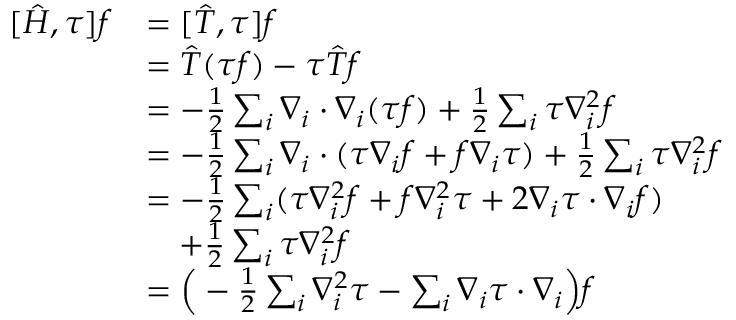Convert formula to latex. <formula><loc_0><loc_0><loc_500><loc_500>\begin{array} { r l } { [ \hat { H } , \tau ] f } & { = [ \hat { T } , \tau ] f } \\ & { = \hat { T } ( \tau f ) - \tau \hat { T } f } \\ & { = - \frac { 1 } { 2 } \sum _ { i } \nabla _ { i } \cdot \nabla _ { i } ( \tau f ) + \frac { 1 } { 2 } \sum _ { i } \tau \nabla _ { i } ^ { 2 } f } \\ & { = - \frac { 1 } { 2 } \sum _ { i } \nabla _ { i } \cdot ( \tau \nabla _ { i } f + f \nabla _ { i } \tau ) + \frac { 1 } { 2 } \sum _ { i } \tau \nabla _ { i } ^ { 2 } f } \\ & { = - \frac { 1 } { 2 } \sum _ { i } ( \tau \nabla _ { i } ^ { 2 } f + f \nabla _ { i } ^ { 2 } \tau + 2 \nabla _ { i } \tau \cdot \nabla _ { i } f ) } \\ & { \quad + \frac { 1 } { 2 } \sum _ { i } \tau \nabla _ { i } ^ { 2 } f } \\ & { = \left ( - \frac { 1 } { 2 } \sum _ { i } \nabla _ { i } ^ { 2 } \tau - \sum _ { i } \nabla _ { i } \tau \cdot \nabla _ { i } \right ) f } \end{array}</formula> 